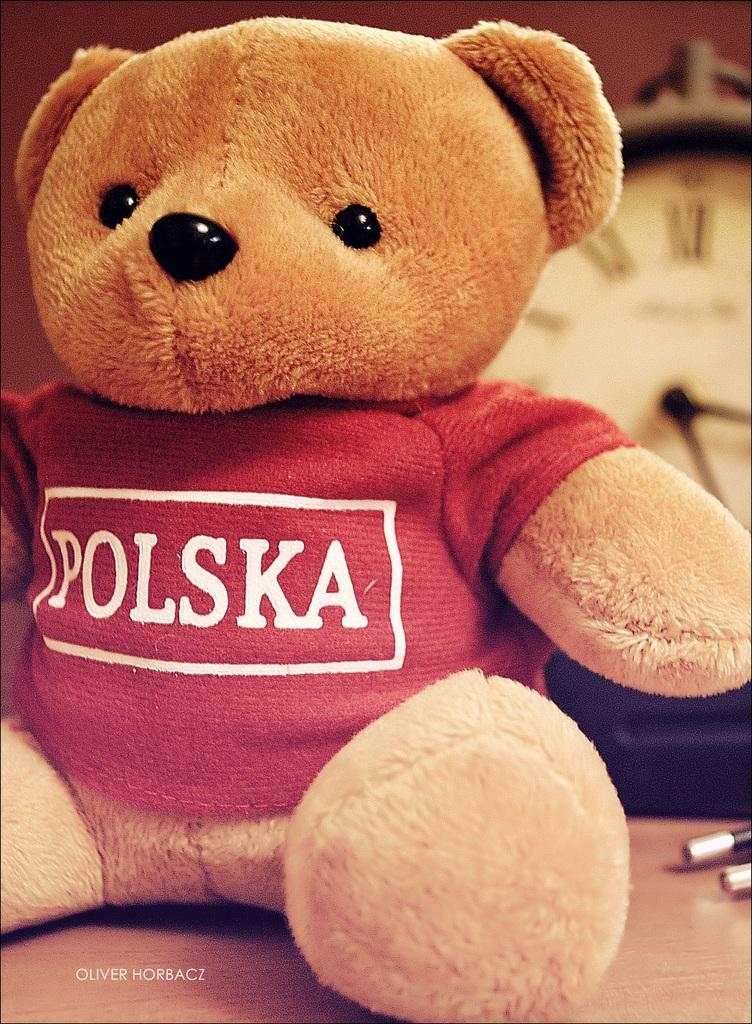What type of object is present on the table in the image? There is a soft toy in the image, and it is on a table. What other object can be seen on the table in the image? There is a clock in the image, and it is on the table as well. What is the wealth of the queen in the image? There is no queen present in the image, and therefore no information about her wealth can be determined. Can you tell me how the sea is depicted in the image? There is no sea present in the image; it features a soft toy and a clock on a table. 